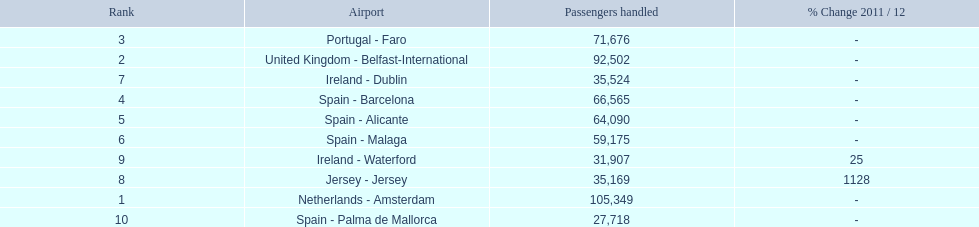What are all of the routes out of the london southend airport? Netherlands - Amsterdam, United Kingdom - Belfast-International, Portugal - Faro, Spain - Barcelona, Spain - Alicante, Spain - Malaga, Ireland - Dublin, Jersey - Jersey, Ireland - Waterford, Spain - Palma de Mallorca. How many passengers have traveled to each destination? 105,349, 92,502, 71,676, 66,565, 64,090, 59,175, 35,524, 35,169, 31,907, 27,718. And which destination has been the most popular to passengers? Netherlands - Amsterdam. 